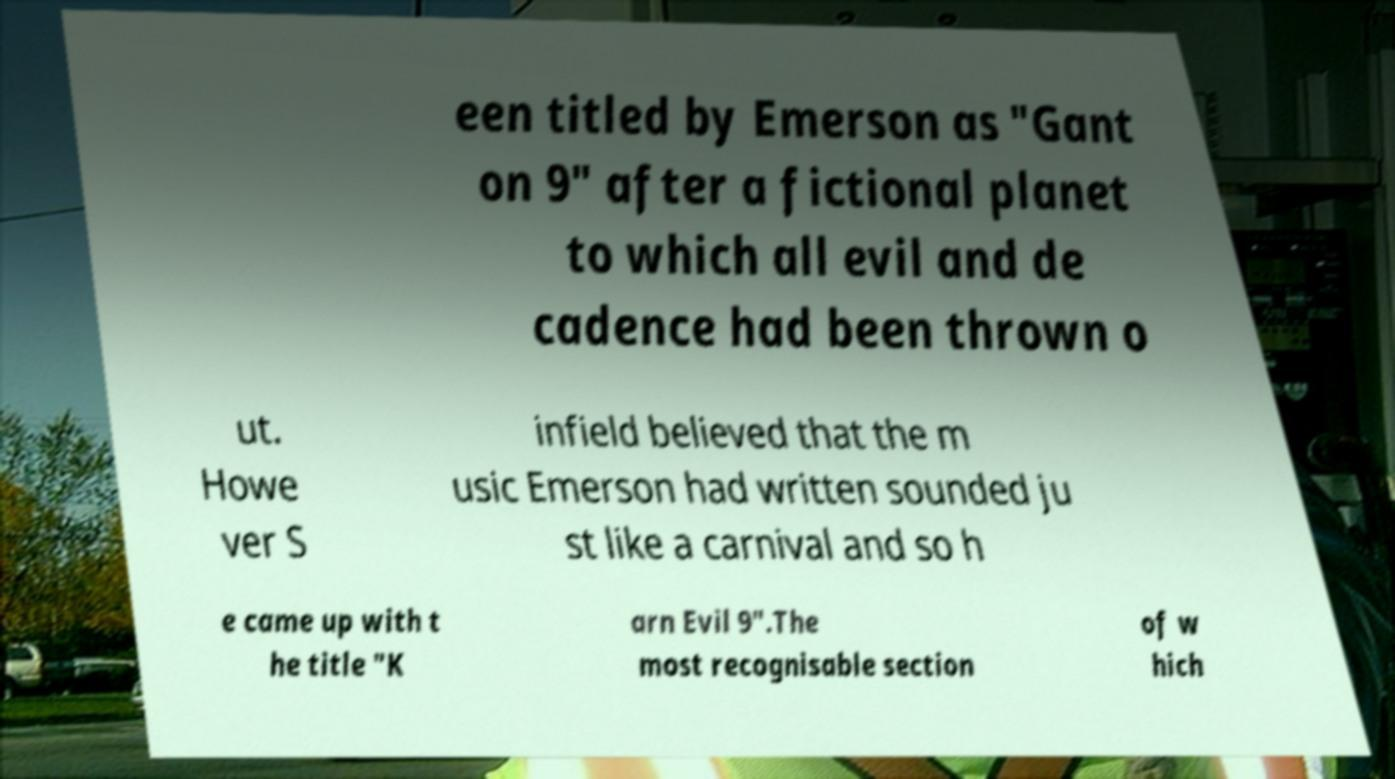I need the written content from this picture converted into text. Can you do that? een titled by Emerson as "Gant on 9" after a fictional planet to which all evil and de cadence had been thrown o ut. Howe ver S infield believed that the m usic Emerson had written sounded ju st like a carnival and so h e came up with t he title "K arn Evil 9".The most recognisable section of w hich 